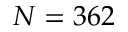<formula> <loc_0><loc_0><loc_500><loc_500>N = 3 6 2</formula> 